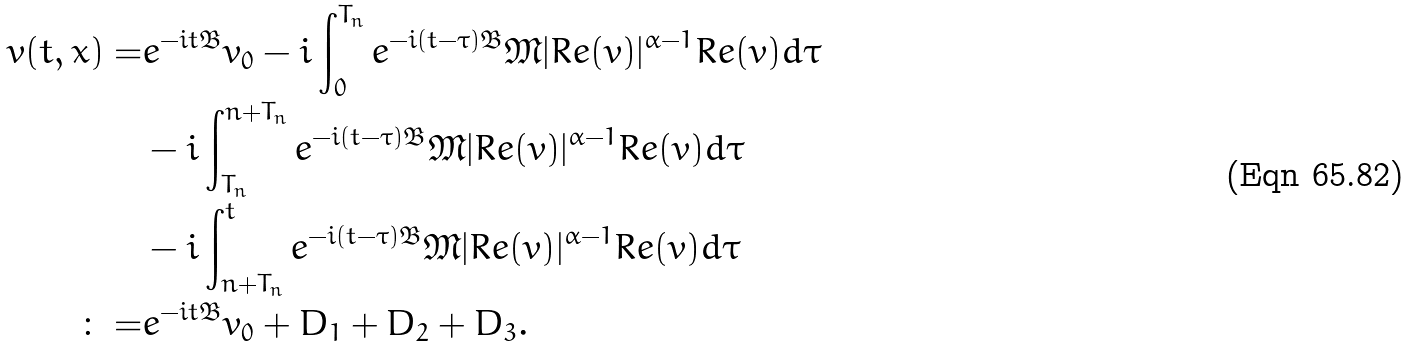<formula> <loc_0><loc_0><loc_500><loc_500>v ( t , x ) = & e ^ { - i t \mathfrak { B } } v _ { 0 } - i \int _ { 0 } ^ { T _ { n } } e ^ { - i ( t - \tau ) \mathfrak { B } } \mathfrak { M } | R e ( v ) | ^ { \alpha - 1 } R e ( v ) d \tau \\ & - i \int _ { T _ { n } } ^ { n + T _ { n } } e ^ { - i ( t - \tau ) \mathfrak { B } } \mathfrak { M } | R e ( v ) | ^ { \alpha - 1 } R e ( v ) d \tau \\ & - i \int _ { n + T _ { n } } ^ { t } e ^ { - i ( t - \tau ) \mathfrak { B } } \mathfrak { M } | R e ( v ) | ^ { \alpha - 1 } R e ( v ) d \tau \\ \colon = & e ^ { - i t \mathfrak { B } } v _ { 0 } + D _ { 1 } + D _ { 2 } + D _ { 3 } .</formula> 